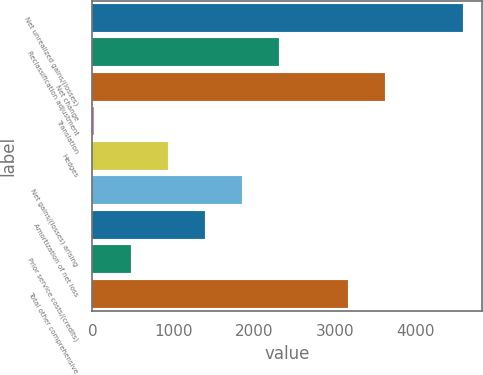<chart> <loc_0><loc_0><loc_500><loc_500><bar_chart><fcel>Net unrealized gains/(losses)<fcel>Reclassification adjustment<fcel>Net change<fcel>Translation<fcel>Hedges<fcel>Net gains/(losses) arising<fcel>Amortization of net loss<fcel>Prior service costs/(credits)<fcel>Total other comprehensive<nl><fcel>4591<fcel>2304.5<fcel>3615.3<fcel>18<fcel>932.6<fcel>1847.2<fcel>1389.9<fcel>475.3<fcel>3158<nl></chart> 